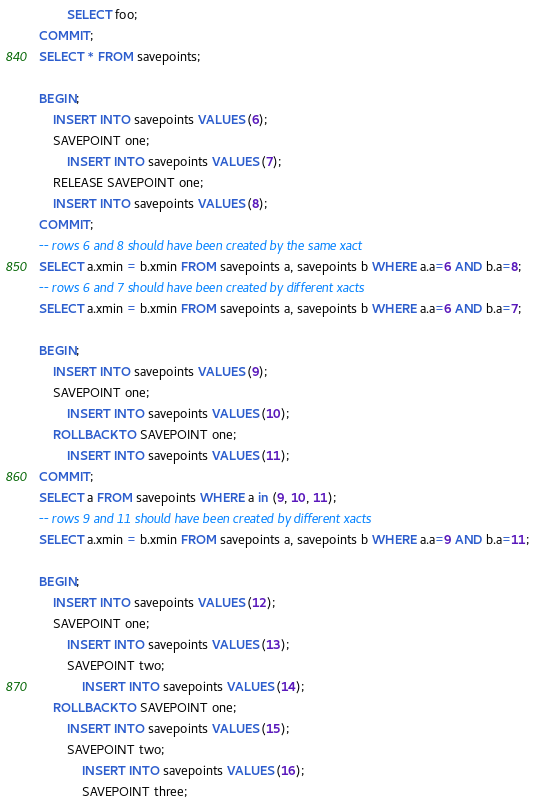<code> <loc_0><loc_0><loc_500><loc_500><_SQL_>		SELECT foo;
COMMIT;
SELECT * FROM savepoints;

BEGIN;
	INSERT INTO savepoints VALUES (6);
	SAVEPOINT one;
		INSERT INTO savepoints VALUES (7);
	RELEASE SAVEPOINT one;
	INSERT INTO savepoints VALUES (8);
COMMIT;
-- rows 6 and 8 should have been created by the same xact
SELECT a.xmin = b.xmin FROM savepoints a, savepoints b WHERE a.a=6 AND b.a=8;
-- rows 6 and 7 should have been created by different xacts
SELECT a.xmin = b.xmin FROM savepoints a, savepoints b WHERE a.a=6 AND b.a=7;

BEGIN;
	INSERT INTO savepoints VALUES (9);
	SAVEPOINT one;
		INSERT INTO savepoints VALUES (10);
	ROLLBACK TO SAVEPOINT one;
		INSERT INTO savepoints VALUES (11);
COMMIT;
SELECT a FROM savepoints WHERE a in (9, 10, 11);
-- rows 9 and 11 should have been created by different xacts
SELECT a.xmin = b.xmin FROM savepoints a, savepoints b WHERE a.a=9 AND b.a=11;

BEGIN;
	INSERT INTO savepoints VALUES (12);
	SAVEPOINT one;
		INSERT INTO savepoints VALUES (13);
		SAVEPOINT two;
			INSERT INTO savepoints VALUES (14);
	ROLLBACK TO SAVEPOINT one;
		INSERT INTO savepoints VALUES (15);
		SAVEPOINT two;
			INSERT INTO savepoints VALUES (16);
			SAVEPOINT three;</code> 